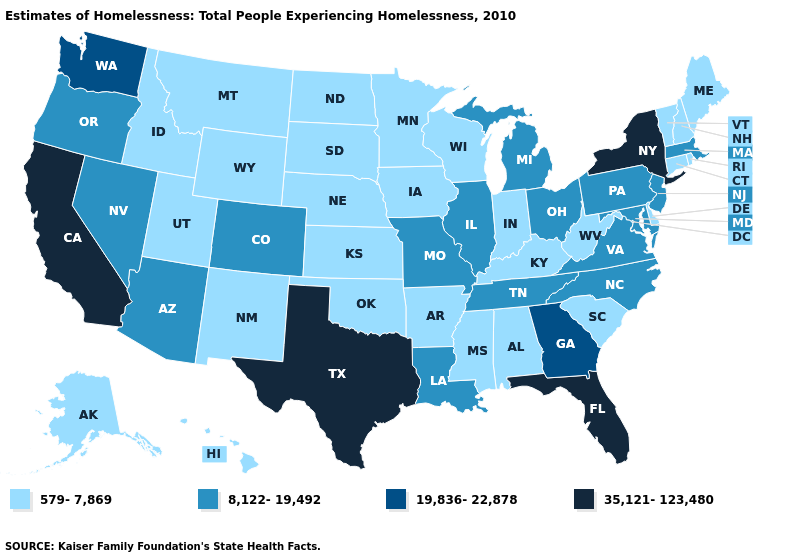Name the states that have a value in the range 579-7,869?
Be succinct. Alabama, Alaska, Arkansas, Connecticut, Delaware, Hawaii, Idaho, Indiana, Iowa, Kansas, Kentucky, Maine, Minnesota, Mississippi, Montana, Nebraska, New Hampshire, New Mexico, North Dakota, Oklahoma, Rhode Island, South Carolina, South Dakota, Utah, Vermont, West Virginia, Wisconsin, Wyoming. Name the states that have a value in the range 579-7,869?
Quick response, please. Alabama, Alaska, Arkansas, Connecticut, Delaware, Hawaii, Idaho, Indiana, Iowa, Kansas, Kentucky, Maine, Minnesota, Mississippi, Montana, Nebraska, New Hampshire, New Mexico, North Dakota, Oklahoma, Rhode Island, South Carolina, South Dakota, Utah, Vermont, West Virginia, Wisconsin, Wyoming. Which states hav the highest value in the West?
Give a very brief answer. California. Among the states that border Tennessee , which have the highest value?
Write a very short answer. Georgia. Does the map have missing data?
Write a very short answer. No. Does the map have missing data?
Write a very short answer. No. Among the states that border Mississippi , does Louisiana have the lowest value?
Answer briefly. No. Does the first symbol in the legend represent the smallest category?
Quick response, please. Yes. Does Louisiana have the same value as Missouri?
Be succinct. Yes. What is the value of Washington?
Write a very short answer. 19,836-22,878. Name the states that have a value in the range 579-7,869?
Answer briefly. Alabama, Alaska, Arkansas, Connecticut, Delaware, Hawaii, Idaho, Indiana, Iowa, Kansas, Kentucky, Maine, Minnesota, Mississippi, Montana, Nebraska, New Hampshire, New Mexico, North Dakota, Oklahoma, Rhode Island, South Carolina, South Dakota, Utah, Vermont, West Virginia, Wisconsin, Wyoming. What is the value of Hawaii?
Quick response, please. 579-7,869. What is the value of Texas?
Quick response, please. 35,121-123,480. What is the value of Michigan?
Quick response, please. 8,122-19,492. Name the states that have a value in the range 35,121-123,480?
Give a very brief answer. California, Florida, New York, Texas. 